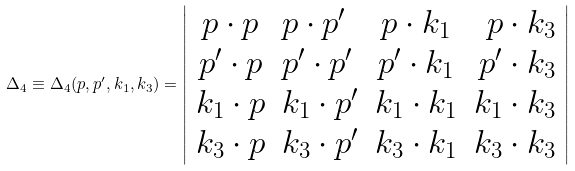Convert formula to latex. <formula><loc_0><loc_0><loc_500><loc_500>\Delta _ { 4 } \equiv \Delta _ { 4 } ( p , p ^ { \prime } , k _ { 1 } , k _ { 3 } ) = \left | \begin{array} { c l c r } { p \cdot p } & { { p \cdot p ^ { \prime } } } & { { p \cdot k _ { 1 } } } & { { p \cdot k _ { 3 } } } \\ { { p ^ { \prime } \cdot p } } & { { p ^ { \prime } \cdot p ^ { \prime } } } & { { p ^ { \prime } \cdot k _ { 1 } } } & { { p ^ { \prime } \cdot k _ { 3 } } } \\ { { k _ { 1 } \cdot p } } & { { k _ { 1 } \cdot p ^ { \prime } } } & { { k _ { 1 } \cdot k _ { 1 } } } & { { k _ { 1 } \cdot k _ { 3 } } } \\ { { k _ { 3 } \cdot p } } & { { k _ { 3 } \cdot p ^ { \prime } } } & { { k _ { 3 } \cdot k _ { 1 } } } & { { k _ { 3 } \cdot k _ { 3 } } } \end{array} \right |</formula> 